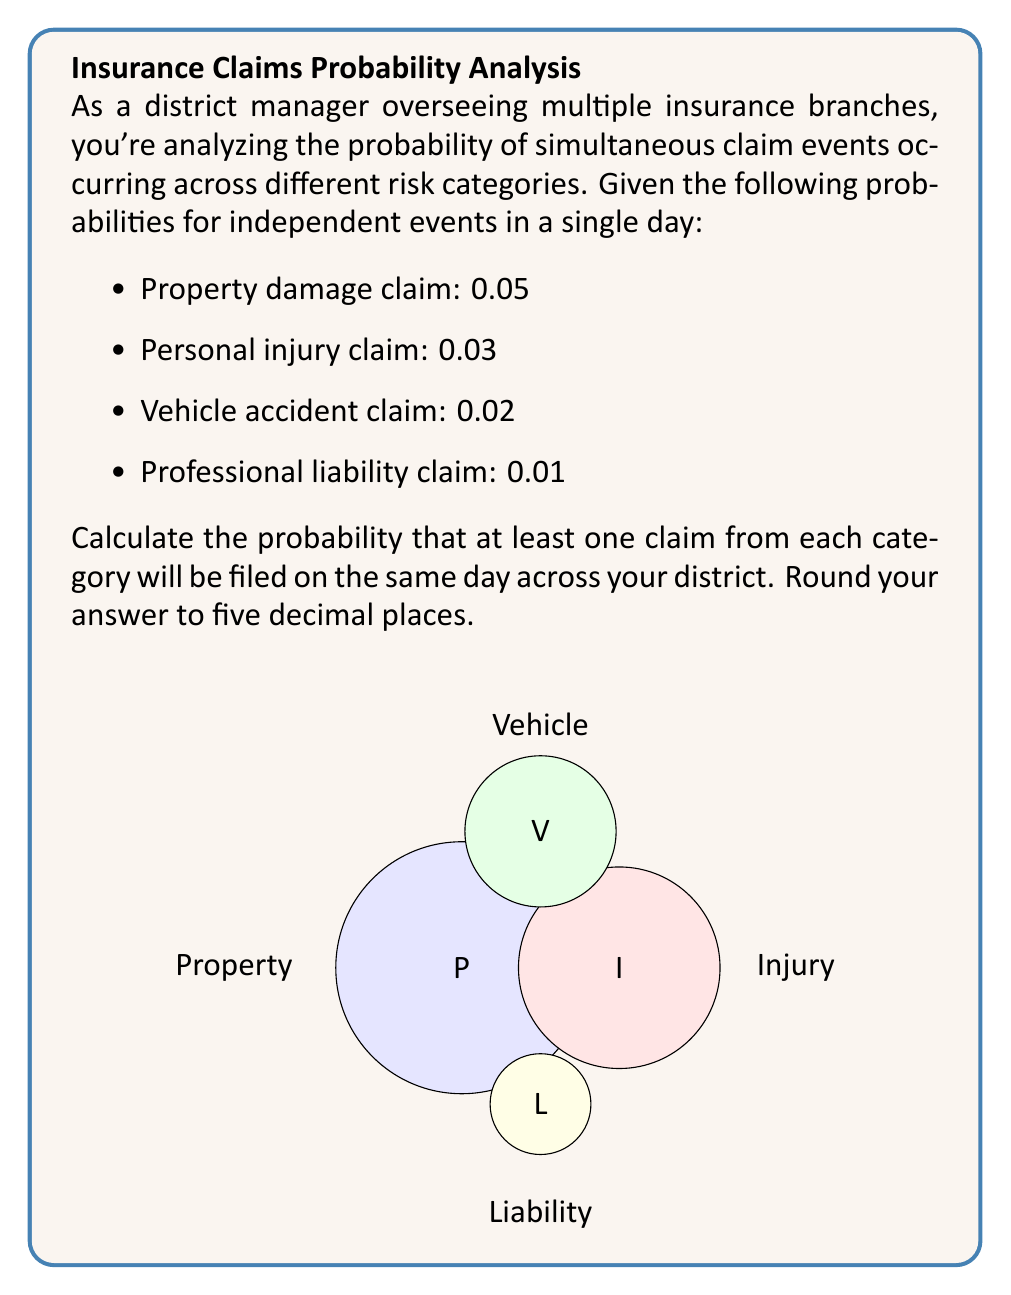Can you answer this question? To solve this problem, we'll use the following steps:

1) First, let's calculate the probability of each event occurring:
   P(Property) = 0.05
   P(Injury) = 0.03
   P(Vehicle) = 0.02
   P(Liability) = 0.01

2) Since we want at least one claim from each category, we need to calculate the probability of not having zero claims in any category. We can do this by subtracting the probability of having zero claims from 1 for each category:

   P(At least one Property) = 1 - P(No Property) = 1 - 0.95 = 0.05
   P(At least one Injury) = 1 - P(No Injury) = 1 - 0.97 = 0.03
   P(At least one Vehicle) = 1 - P(No Vehicle) = 1 - 0.98 = 0.02
   P(At least one Liability) = 1 - P(No Liability) = 1 - 0.99 = 0.01

3) Now, we need to calculate the probability of all these events occurring simultaneously. Since the events are independent, we multiply their individual probabilities:

   $$P(\text{All occur}) = 0.05 \times 0.03 \times 0.02 \times 0.01$$

4) Let's calculate this:

   $$P(\text{All occur}) = 0.05 \times 0.03 \times 0.02 \times 0.01 = 0.0000003$$

5) Rounding to five decimal places:

   $$P(\text{All occur}) \approx 0.00000$$

Therefore, the probability of at least one claim from each category being filed on the same day across your district is approximately 0.00000 (rounded to five decimal places).
Answer: 0.00000 